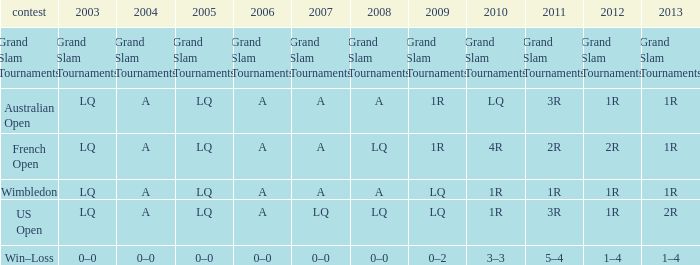Which year has a 2003 of lq? 1R, 1R, LQ, LQ. 